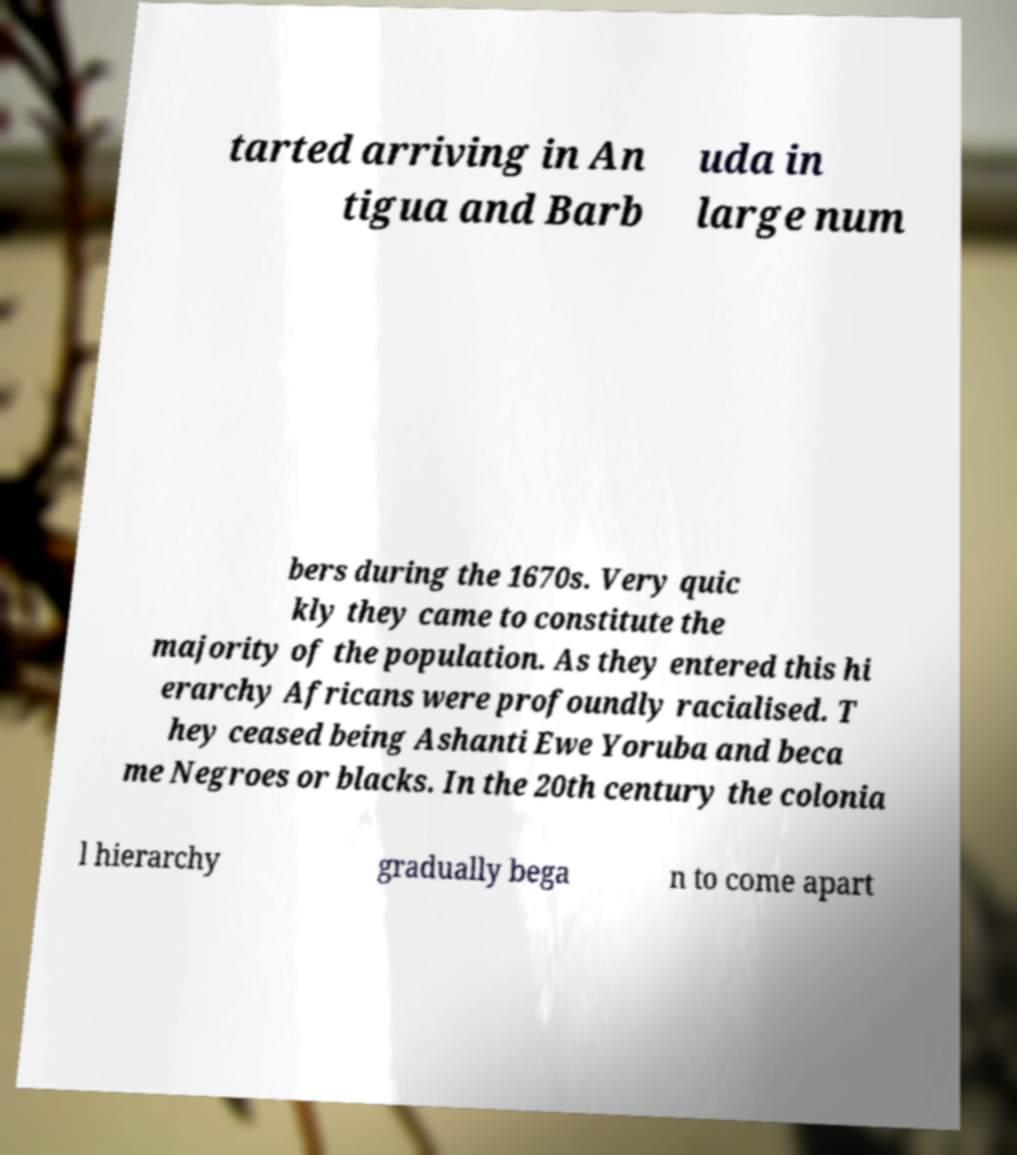Could you extract and type out the text from this image? tarted arriving in An tigua and Barb uda in large num bers during the 1670s. Very quic kly they came to constitute the majority of the population. As they entered this hi erarchy Africans were profoundly racialised. T hey ceased being Ashanti Ewe Yoruba and beca me Negroes or blacks. In the 20th century the colonia l hierarchy gradually bega n to come apart 